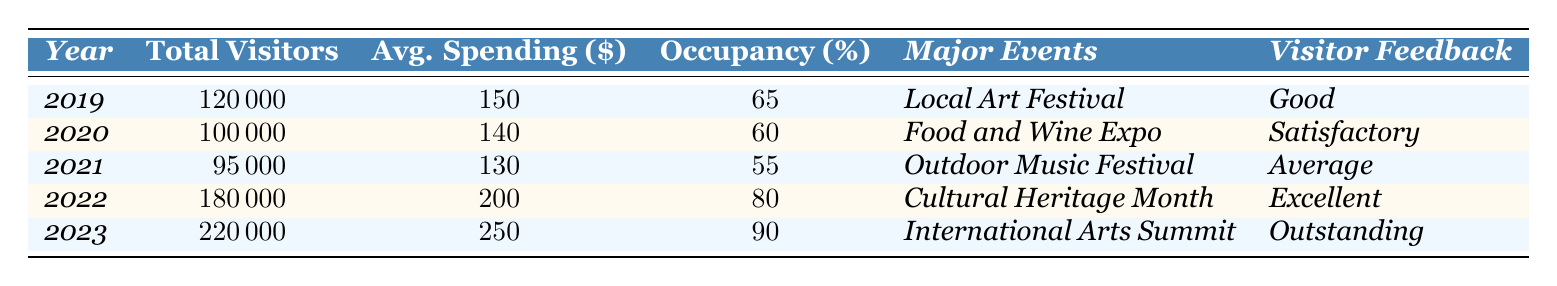What was the total number of visitors in 2022? According to the table, the total number of visitors in 2022 is directly listed as 180,000.
Answer: 180000 What was the average spending per visitor in 2023? The table indicates that the average spending per visitor in 2023 is 250 dollars.
Answer: 250 In which year did the hotel occupancy rate reach 90%? The table shows that the hotel occupancy rate reached 90% in the year 2023.
Answer: 2023 How many more total visitors were there in 2023 compared to 2019? The total visitors in 2023 is 220,000 and in 2019 it was 120,000. The difference is 220,000 - 120,000 = 100,000.
Answer: 100000 Was the visitor feedback in 2022 'Excellent'? The table indicates that the visitor feedback for 2022 was rated as 'Excellent', thus the answer is true.
Answer: True What was the trend in total visitors from 2019 to 2023? The total visitors increased from 120,000 in 2019 to 220,000 in 2023, showing a positive growth trend over these years.
Answer: Positive growth What is the average hotel occupancy rate from 2019 to 2023? To find the average, we sum the hotel occupancy rates: (65 + 60 + 55 + 80 + 90) = 350, then divide by 5 years: 350 / 5 = 70.
Answer: 70 In which year was the average spending per visitor the lowest? By comparing the average spending from each year, we see it was lowest in 2021 at 130 dollars.
Answer: 2021 Which major event took place in 2022? According to the table, the major event in 2022 was the 'Cultural Heritage Month'.
Answer: Cultural Heritage Month What was the percentage increase in total visitors from 2021 to 2022? The total visitors increased from 95,000 in 2021 to 180,000 in 2022. The increase is 180,000 - 95,000 = 85,000. The percentage increase is (85,000 / 95,000) × 100 ≈ 89.47%.
Answer: Approximately 89.47% 